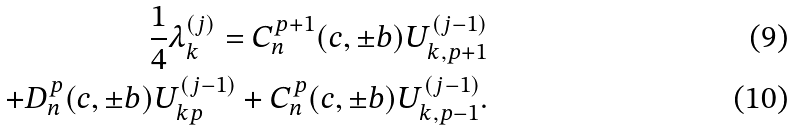<formula> <loc_0><loc_0><loc_500><loc_500>\frac { 1 } { 4 } { \lambda } _ { k } ^ { ( j ) } = C _ { n } ^ { p + 1 } ( c , \pm b ) U _ { k , p + 1 } ^ { ( j - 1 ) } \\ + D _ { n } ^ { p } ( c , \pm b ) U _ { k p } ^ { ( j - 1 ) } + C _ { n } ^ { p } ( c , \pm b ) U _ { k , p - 1 } ^ { ( j - 1 ) } .</formula> 